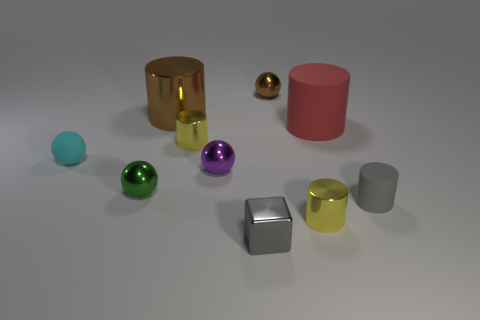Subtract all brown metallic balls. How many balls are left? 3 Subtract all balls. How many objects are left? 6 Subtract all brown blocks. How many yellow cylinders are left? 2 Subtract all gray cylinders. How many cylinders are left? 4 Subtract 2 balls. How many balls are left? 2 Subtract all gray spheres. Subtract all red cylinders. How many spheres are left? 4 Subtract all green spheres. Subtract all small purple objects. How many objects are left? 8 Add 1 shiny objects. How many shiny objects are left? 8 Add 6 tiny matte things. How many tiny matte things exist? 8 Subtract 0 red cubes. How many objects are left? 10 